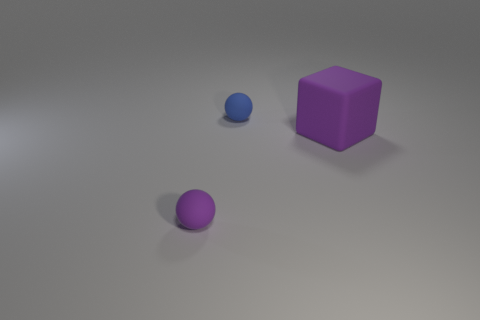Add 2 green rubber cubes. How many objects exist? 5 Subtract all balls. How many objects are left? 1 Subtract all spheres. Subtract all purple blocks. How many objects are left? 0 Add 1 rubber cubes. How many rubber cubes are left? 2 Add 3 small rubber balls. How many small rubber balls exist? 5 Subtract 0 cyan spheres. How many objects are left? 3 Subtract 1 balls. How many balls are left? 1 Subtract all yellow spheres. Subtract all green cylinders. How many spheres are left? 2 Subtract all gray cylinders. How many purple balls are left? 1 